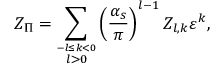Convert formula to latex. <formula><loc_0><loc_0><loc_500><loc_500>Z _ { \Pi } = \sum _ { \stackrel { - l \leq k < 0 } { l > 0 } } \left ( \frac { \alpha _ { s } } { \pi } \right ) ^ { l - 1 } Z _ { l , k } \varepsilon ^ { k } ,</formula> 